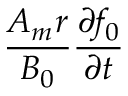<formula> <loc_0><loc_0><loc_500><loc_500>\frac { A _ { m } r } { B _ { 0 } } \frac { \partial f _ { 0 } } { \partial t }</formula> 